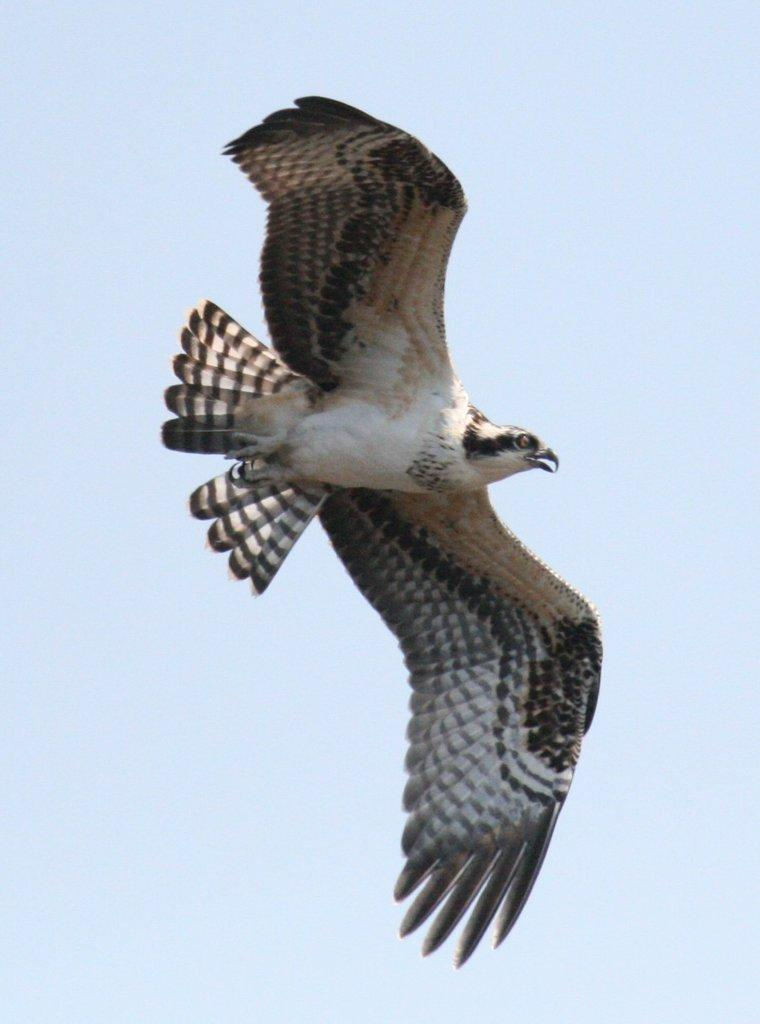What type of animal can be seen in the image? There is a bird in the image. What is the bird doing in the image? The bird is flying in the sky. What type of insurance does the bird have in the image? There is no mention of insurance in the image, as it features a bird flying in the sky. How many visitors are present in the image? There are no visitors present in the image, as it only features a bird flying in the sky. 